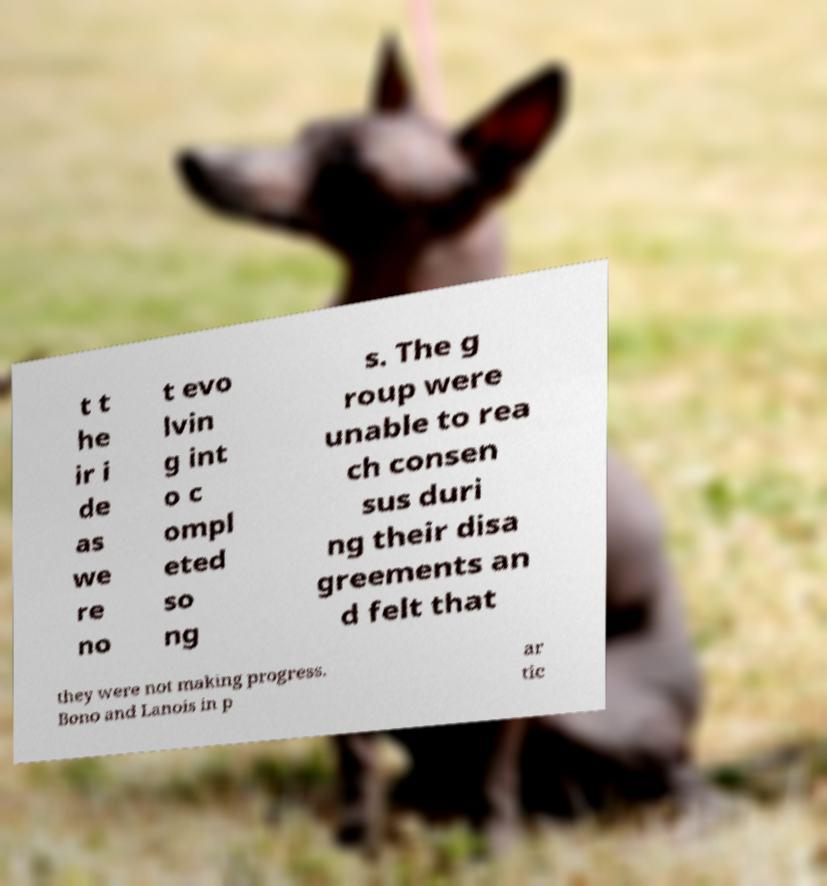Please read and relay the text visible in this image. What does it say? t t he ir i de as we re no t evo lvin g int o c ompl eted so ng s. The g roup were unable to rea ch consen sus duri ng their disa greements an d felt that they were not making progress. Bono and Lanois in p ar tic 